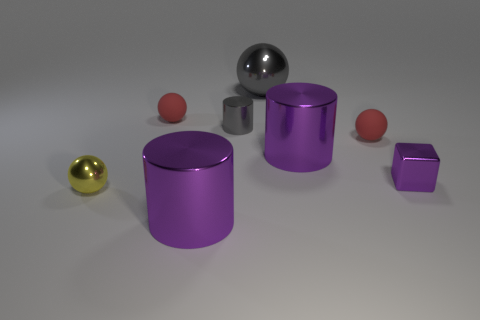How many other things are there of the same color as the tiny shiny cube?
Your response must be concise. 2. Is the number of yellow metal things less than the number of red cylinders?
Ensure brevity in your answer.  No. There is a red matte thing that is in front of the red object that is behind the small gray object; what shape is it?
Your response must be concise. Sphere. There is a tiny yellow sphere; are there any tiny yellow shiny spheres behind it?
Keep it short and to the point. No. The metallic ball that is the same size as the purple metallic block is what color?
Ensure brevity in your answer.  Yellow. What number of large objects have the same material as the small gray thing?
Keep it short and to the point. 3. What number of other objects are there of the same size as the yellow metallic thing?
Your response must be concise. 4. Is there a purple shiny cylinder that has the same size as the gray sphere?
Your answer should be very brief. Yes. There is a big object right of the big gray shiny ball; is its color the same as the small metallic block?
Make the answer very short. Yes. How many objects are tiny cylinders or tiny shiny things?
Your answer should be compact. 3. 